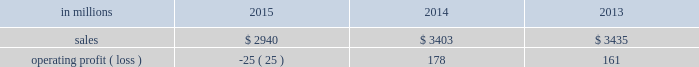Augusta , georgia mill and $ 2 million of costs associated with the sale of the shorewood business .
Consumer packaging .
North american consumer packaging net sales were $ 1.9 billion in 2015 compared with $ 2.0 billion in 2014 and $ 2.0 billion in 2013 .
Operating profits were $ 81 million ( $ 91 million excluding the cost associated with the planned conversion of our riegelwood mill to 100% ( 100 % ) pulp production , net of proceeds from the sale of the carolina coated bristols brand , and sheet plant closure costs ) in 2015 compared with $ 92 million ( $ 100 million excluding sheet plant closure costs ) in 2014 and $ 63 million ( $ 110 million excluding paper machine shutdown costs and costs related to the sale of the shorewood business ) in 2013 .
Coated paperboard sales volumes in 2015 were lower than in 2014 reflecting weaker market demand .
The business took about 77000 tons of market-related downtime in 2015 compared with about 41000 tons in 2014 .
Average sales price realizations increased modestly year over year as competitive pressures in the current year only partially offset the impact of sales price increases implemented in 2014 .
Input costs decreased for energy and chemicals , but wood costs increased .
Planned maintenance downtime costs were $ 10 million lower in 2015 .
Operating costs were higher , mainly due to inflation and overhead costs .
Foodservice sales volumes increased in 2015 compared with 2014 reflecting strong market demand .
Average sales margins increased due to lower resin costs and a more favorable mix .
Operating costs and distribution costs were both higher .
Looking ahead to the first quarter of 2016 , coated paperboard sales volumes are expected to be slightly lower than in the fourth quarter of 2015 due to our exit from the coated bristols market .
Average sales price realizations are expected to be flat , but margins should benefit from a more favorable product mix .
Input costs are expected to be higher for wood , chemicals and energy .
Planned maintenance downtime costs should be $ 4 million higher with a planned maintenance outage scheduled at our augusta mill in the first quarter .
Foodservice sales volumes are expected to be seasonally lower .
Average sales margins are expected to improve due to a more favorable mix .
Operating costs are expected to decrease .
European consumer packaging net sales in 2015 were $ 319 million compared with $ 365 million in 2014 and $ 380 million in 2013 .
Operating profits in 2015 were $ 87 million compared with $ 91 million in 2014 and $ 100 million in 2013 .
Sales volumes in 2015 compared with 2014 increased in europe , but decreased in russia .
Average sales margins improved in russia due to slightly higher average sales price realizations and a more favorable mix .
In europe average sales margins decreased reflecting lower average sales price realizations and an unfavorable mix .
Input costs were lower in europe , primarily for wood and energy , but were higher in russia , primarily for wood .
Looking forward to the first quarter of 2016 , compared with the fourth quarter of 2015 , sales volumes are expected to be stable .
Average sales price realizations are expected to be slightly higher in both russia and europe .
Input costs are expected to be flat , while operating costs are expected to increase .
Asian consumer packaging the company sold its 55% ( 55 % ) equity share in the ip-sun jv in october 2015 .
Net sales and operating profits presented below include results through september 30 , 2015 .
Net sales were $ 682 million in 2015 compared with $ 1.0 billion in 2014 and $ 1.1 billion in 2013 .
Operating profits in 2015 were a loss of $ 193 million ( a loss of $ 19 million excluding goodwill and other asset impairment costs ) compared with losses of $ 5 million in 2014 and $ 2 million in 2013 .
Sales volumes and average sales price realizations were lower in 2015 due to over-supplied market conditions and competitive pressures .
Average sales margins were also negatively impacted by a less favorable mix .
Input costs and freight costs were lower and operating costs also decreased .
On october 13 , 2015 , the company finalized the sale of its 55% ( 55 % ) interest in ip asia coated paperboard ( ip- sun jv ) business , within the company's consumer packaging segment , to its chinese coated board joint venture partner , shandong sun holding group co. , ltd .
For rmb 149 million ( approximately usd $ 23 million ) .
During the third quarter of 2015 , a determination was made that the current book value of the asset group exceeded its estimated fair value of $ 23 million , which was the agreed upon selling price .
The 2015 loss includes the net pre-tax impairment charge of $ 174 million ( $ 113 million after taxes ) .
A pre-tax charge of $ 186 million was recorded during the third quarter in the company's consumer packaging segment to write down the long-lived assets of this business to their estimated fair value .
In the fourth quarter of 2015 , upon the sale and corresponding deconsolidation of ip-sun jv from the company's consolidated balance sheet , final adjustments were made resulting in a reduction of the impairment of $ 12 million .
The amount of pre-tax losses related to noncontrolling interest of the ip-sun jv included in the company's consolidated statement of operations for the years ended december 31 , 2015 , 2014 and 2013 were $ 19 million , $ 12 million and $ 8 million , respectively .
The amount of pre-tax losses related to the ip-sun jv included in the company's .
What percentage of consumer packaging sales where from north american consumer packaging in 2014? 
Computations: ((2 * 1000) / 3403)
Answer: 0.58772. 